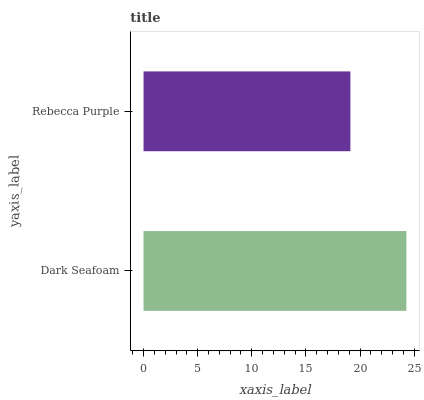Is Rebecca Purple the minimum?
Answer yes or no. Yes. Is Dark Seafoam the maximum?
Answer yes or no. Yes. Is Rebecca Purple the maximum?
Answer yes or no. No. Is Dark Seafoam greater than Rebecca Purple?
Answer yes or no. Yes. Is Rebecca Purple less than Dark Seafoam?
Answer yes or no. Yes. Is Rebecca Purple greater than Dark Seafoam?
Answer yes or no. No. Is Dark Seafoam less than Rebecca Purple?
Answer yes or no. No. Is Dark Seafoam the high median?
Answer yes or no. Yes. Is Rebecca Purple the low median?
Answer yes or no. Yes. Is Rebecca Purple the high median?
Answer yes or no. No. Is Dark Seafoam the low median?
Answer yes or no. No. 